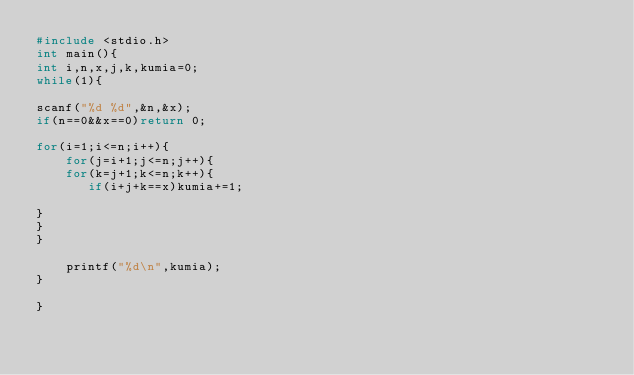Convert code to text. <code><loc_0><loc_0><loc_500><loc_500><_C_>#include <stdio.h>
int main(){
int i,n,x,j,k,kumia=0;
while(1){

scanf("%d %d",&n,&x);
if(n==0&&x==0)return 0;

for(i=1;i<=n;i++){
    for(j=i+1;j<=n;j++){
    for(k=j+1;k<=n;k++){
       if(i+j+k==x)kumia+=1;

}
}
}

    printf("%d\n",kumia);
}

}</code> 